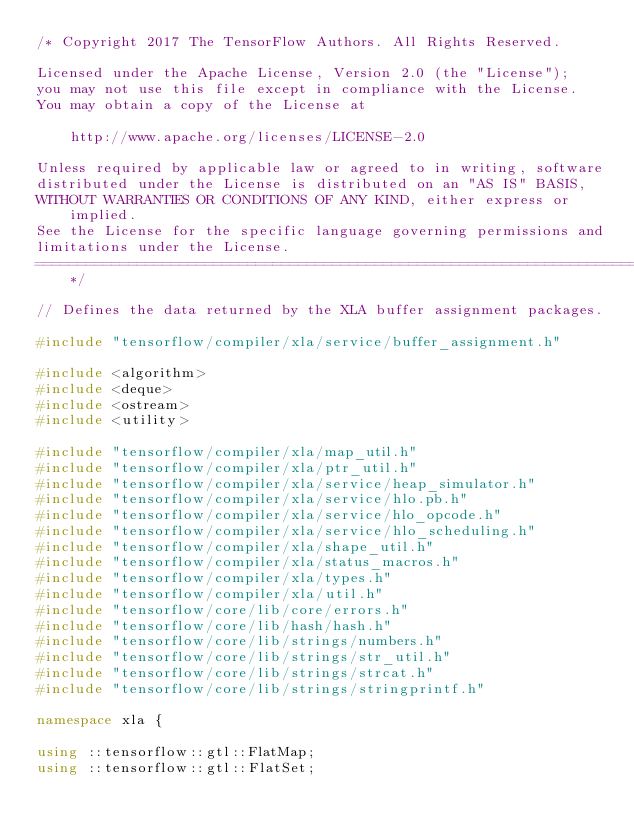Convert code to text. <code><loc_0><loc_0><loc_500><loc_500><_C++_>/* Copyright 2017 The TensorFlow Authors. All Rights Reserved.

Licensed under the Apache License, Version 2.0 (the "License");
you may not use this file except in compliance with the License.
You may obtain a copy of the License at

    http://www.apache.org/licenses/LICENSE-2.0

Unless required by applicable law or agreed to in writing, software
distributed under the License is distributed on an "AS IS" BASIS,
WITHOUT WARRANTIES OR CONDITIONS OF ANY KIND, either express or implied.
See the License for the specific language governing permissions and
limitations under the License.
==============================================================================*/

// Defines the data returned by the XLA buffer assignment packages.

#include "tensorflow/compiler/xla/service/buffer_assignment.h"

#include <algorithm>
#include <deque>
#include <ostream>
#include <utility>

#include "tensorflow/compiler/xla/map_util.h"
#include "tensorflow/compiler/xla/ptr_util.h"
#include "tensorflow/compiler/xla/service/heap_simulator.h"
#include "tensorflow/compiler/xla/service/hlo.pb.h"
#include "tensorflow/compiler/xla/service/hlo_opcode.h"
#include "tensorflow/compiler/xla/service/hlo_scheduling.h"
#include "tensorflow/compiler/xla/shape_util.h"
#include "tensorflow/compiler/xla/status_macros.h"
#include "tensorflow/compiler/xla/types.h"
#include "tensorflow/compiler/xla/util.h"
#include "tensorflow/core/lib/core/errors.h"
#include "tensorflow/core/lib/hash/hash.h"
#include "tensorflow/core/lib/strings/numbers.h"
#include "tensorflow/core/lib/strings/str_util.h"
#include "tensorflow/core/lib/strings/strcat.h"
#include "tensorflow/core/lib/strings/stringprintf.h"

namespace xla {

using ::tensorflow::gtl::FlatMap;
using ::tensorflow::gtl::FlatSet;</code> 